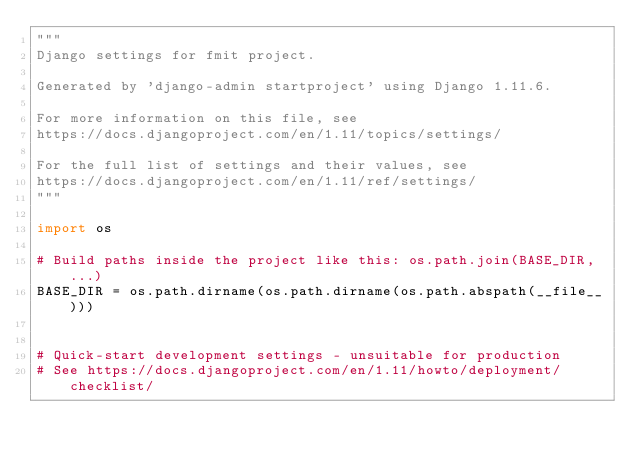Convert code to text. <code><loc_0><loc_0><loc_500><loc_500><_Python_>"""
Django settings for fmit project.

Generated by 'django-admin startproject' using Django 1.11.6.

For more information on this file, see
https://docs.djangoproject.com/en/1.11/topics/settings/

For the full list of settings and their values, see
https://docs.djangoproject.com/en/1.11/ref/settings/
"""

import os

# Build paths inside the project like this: os.path.join(BASE_DIR, ...)
BASE_DIR = os.path.dirname(os.path.dirname(os.path.abspath(__file__)))


# Quick-start development settings - unsuitable for production
# See https://docs.djangoproject.com/en/1.11/howto/deployment/checklist/
</code> 